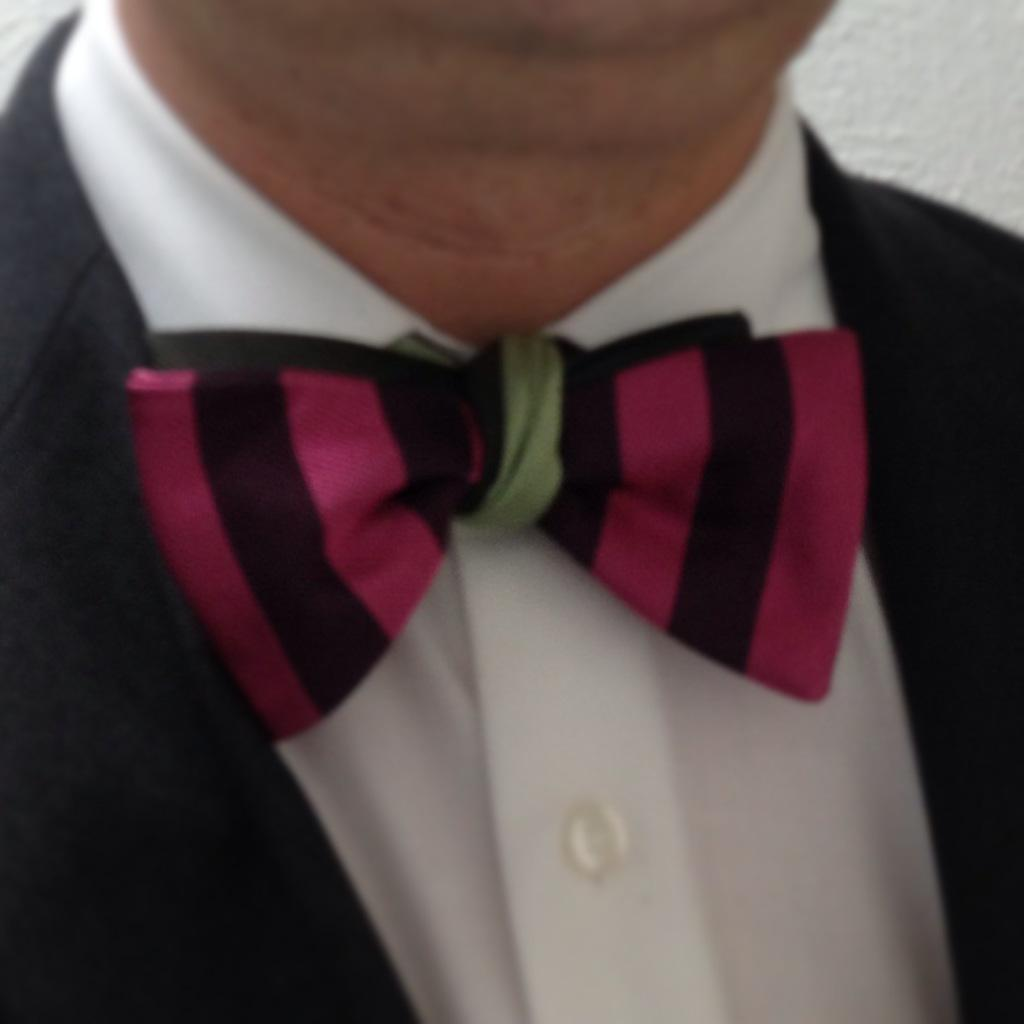Who is present in the image? There is a person in the image. What is the person wearing on their upper body? The person is wearing a white shirt and a black blazer. What color is the wall in the background of the image? The wall in the background of the image is white. What type of music is the person playing on the rake in the image? There is no rake or music present in the image; it only features a person wearing a white shirt and a black blazer in front of a white wall. 